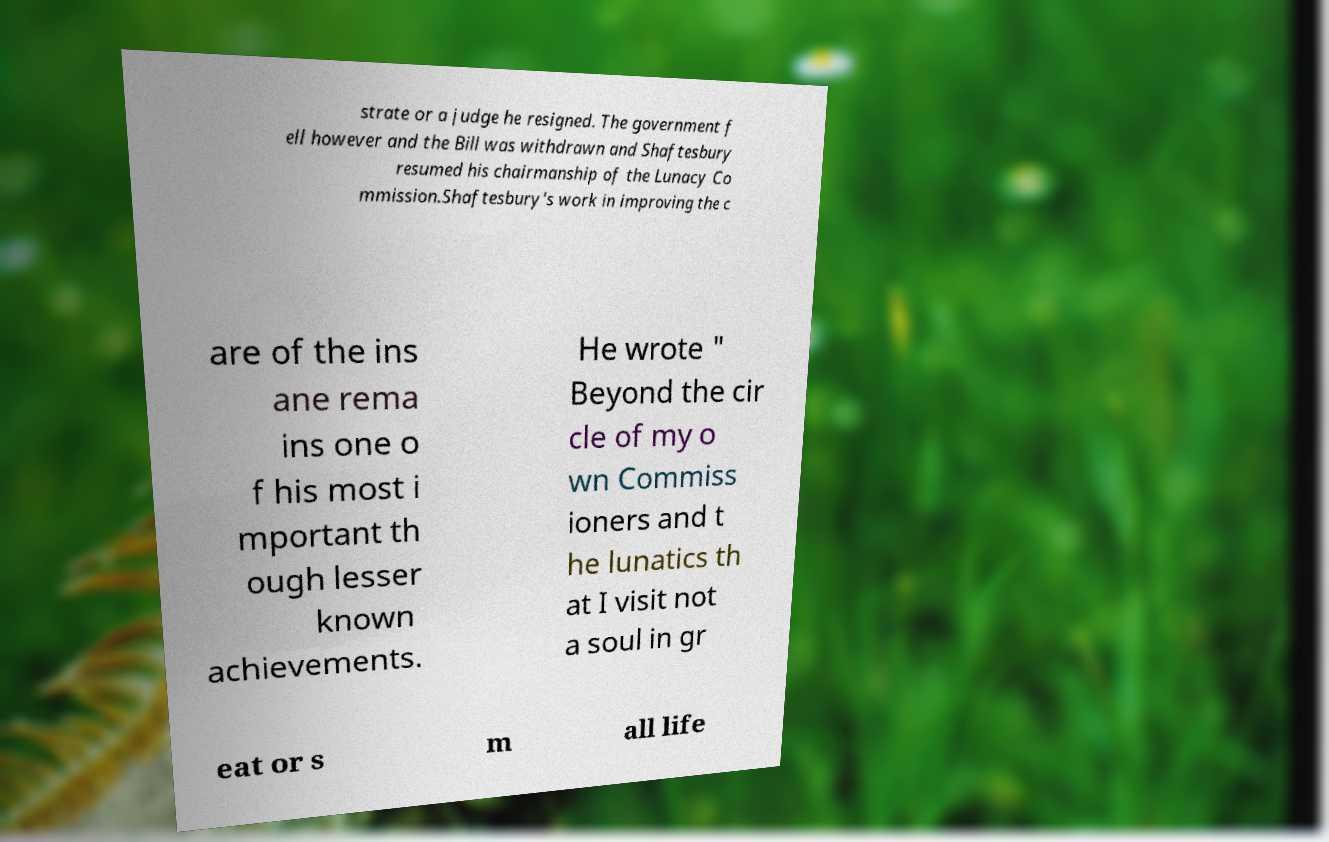What messages or text are displayed in this image? I need them in a readable, typed format. strate or a judge he resigned. The government f ell however and the Bill was withdrawn and Shaftesbury resumed his chairmanship of the Lunacy Co mmission.Shaftesbury's work in improving the c are of the ins ane rema ins one o f his most i mportant th ough lesser known achievements. He wrote " Beyond the cir cle of my o wn Commiss ioners and t he lunatics th at I visit not a soul in gr eat or s m all life 